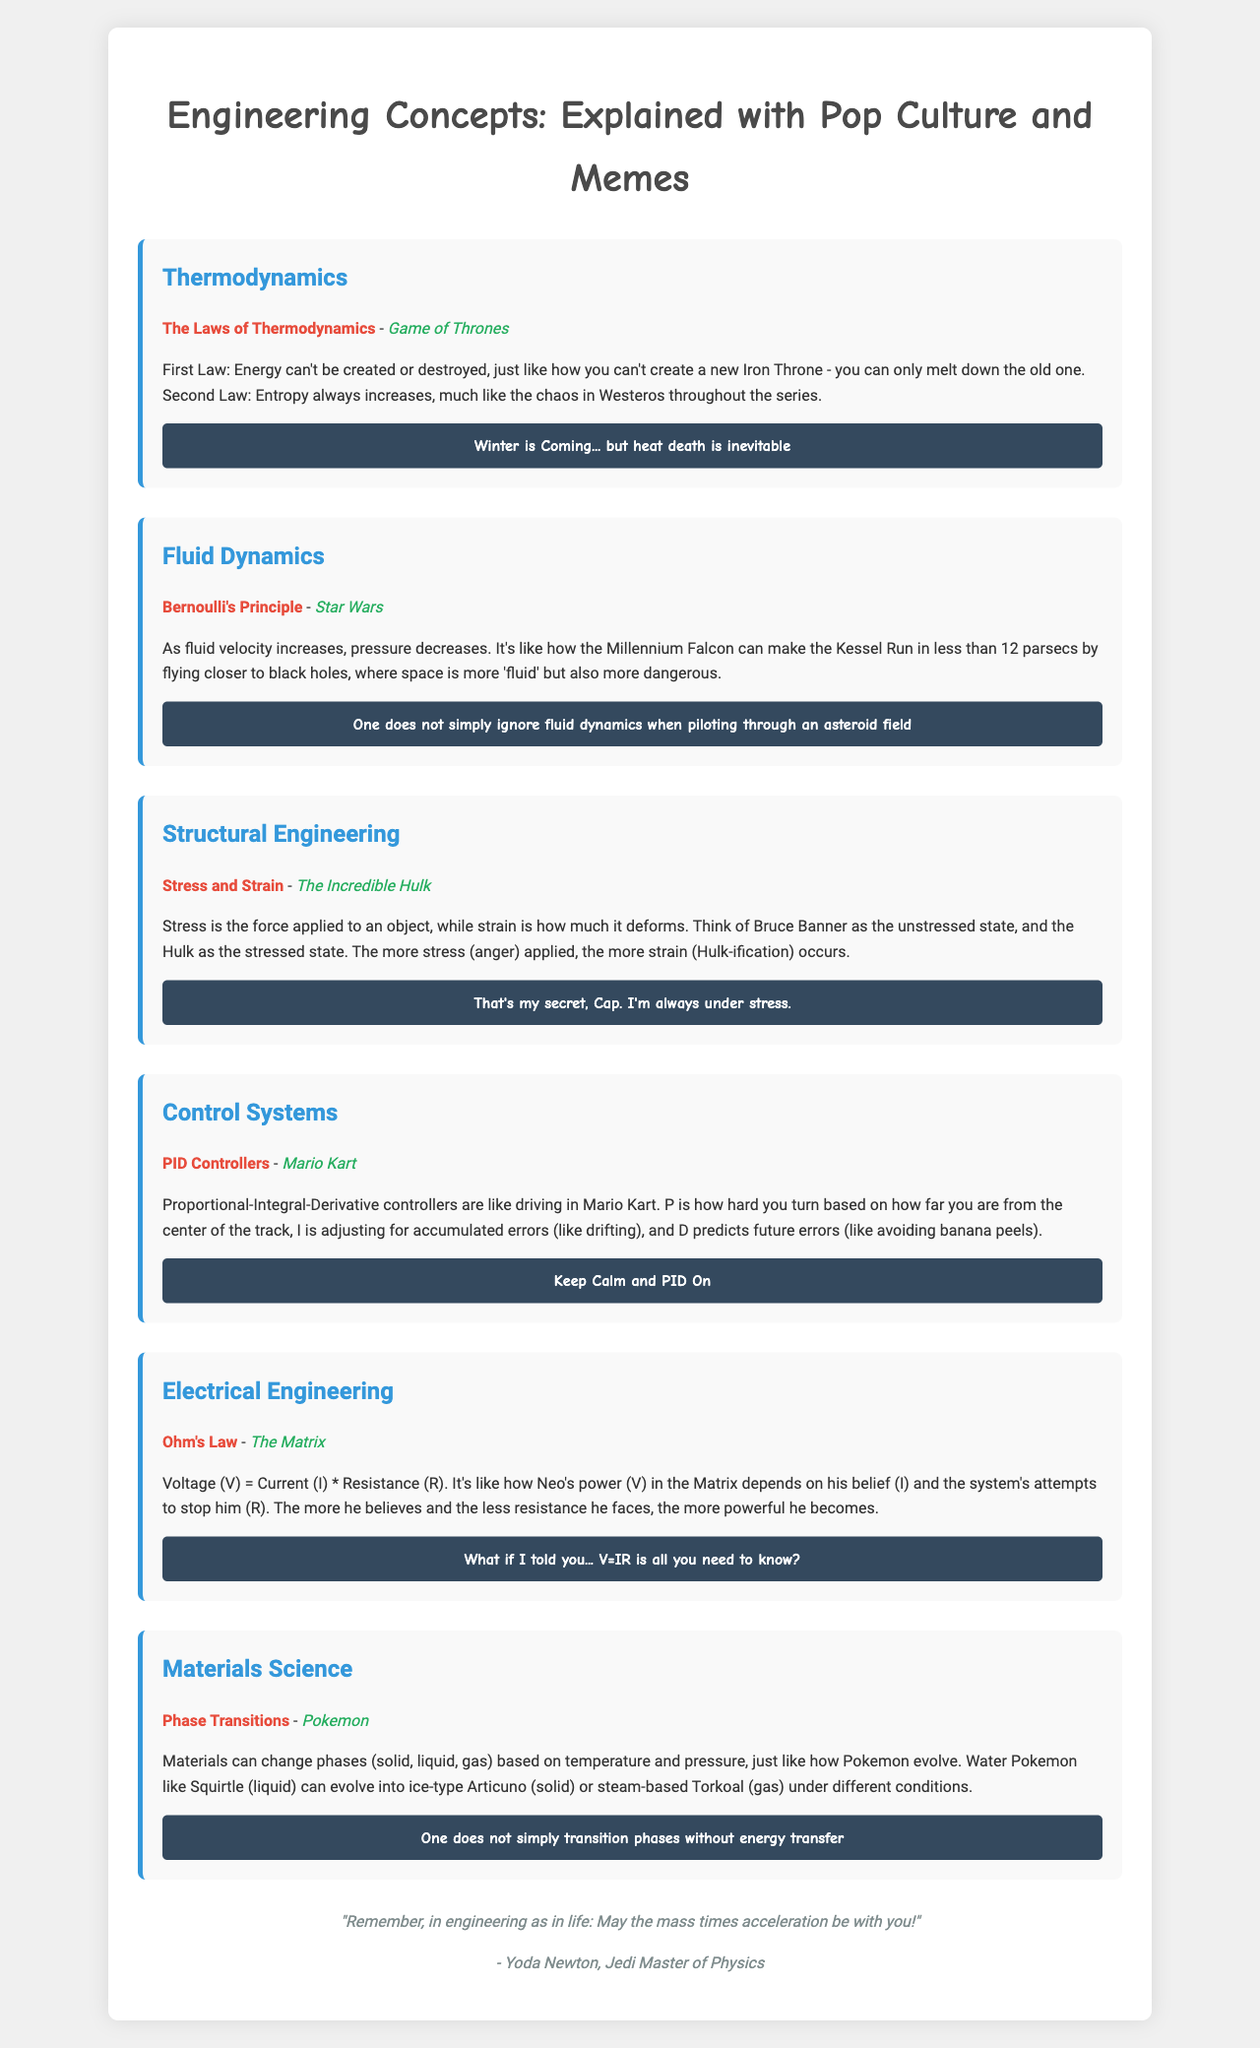What is the title of the brochure? The title is stated at the top of the document as the main heading.
Answer: Engineering Concepts: Explained with Pop Culture and Memes How many sections are in the document? The number of sections is indicated by counting the provided segments.
Answer: Six What pop culture reference is used for Thermodynamics? The pop culture reference is associated with the explanation of the concept in the section.
Answer: Game of Thrones What is the meme associated with Structural Engineering? The meme is included at the end of each section to complement the explanation.
Answer: That's my secret, Cap. I'm always under stress Who is the author mentioned in the footer? The author is credited at the bottom of the document.
Answer: Yoda Newton, Jedi Master of Physics What principle is explained using Star Wars? The principle is highlighted in the respective section with a specific context.
Answer: Bernoulli's Principle 